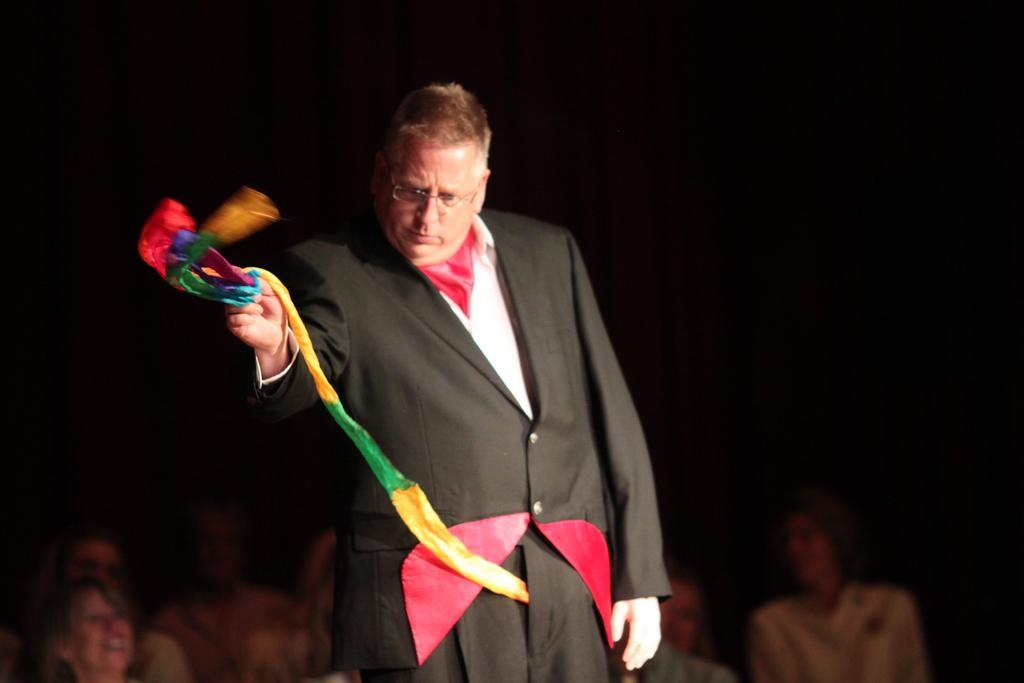In one or two sentences, can you explain what this image depicts? This is the man standing and holding a colorful cloth. At the bottom of the image, I can see a group of people. The background looks dark. 